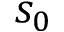Convert formula to latex. <formula><loc_0><loc_0><loc_500><loc_500>s _ { 0 }</formula> 